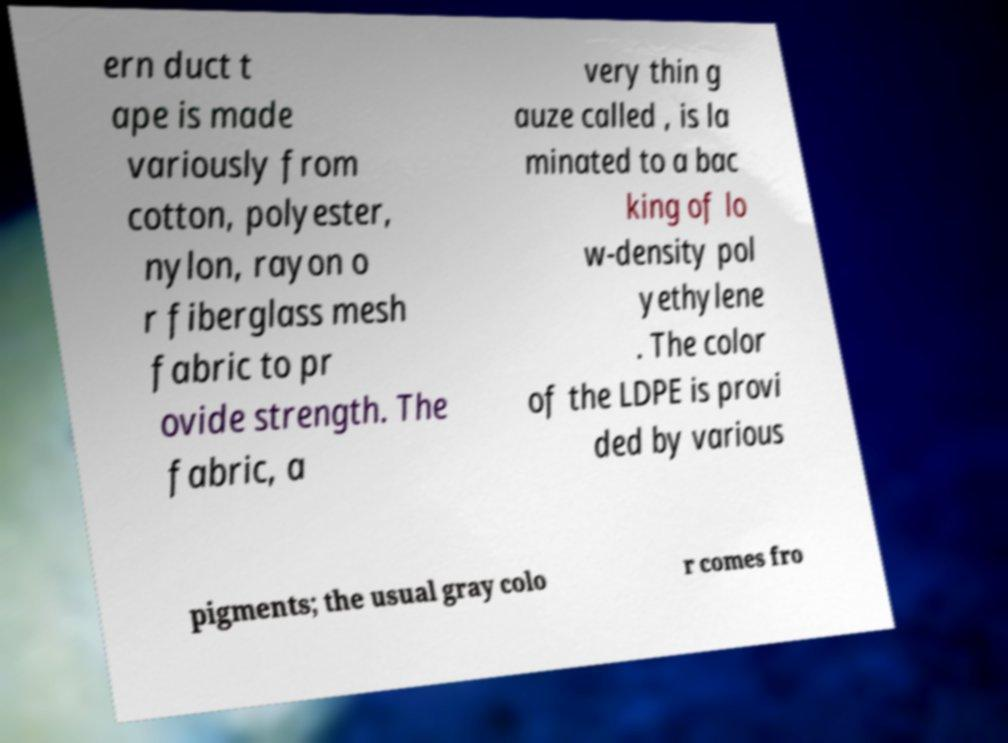What messages or text are displayed in this image? I need them in a readable, typed format. ern duct t ape is made variously from cotton, polyester, nylon, rayon o r fiberglass mesh fabric to pr ovide strength. The fabric, a very thin g auze called , is la minated to a bac king of lo w-density pol yethylene . The color of the LDPE is provi ded by various pigments; the usual gray colo r comes fro 